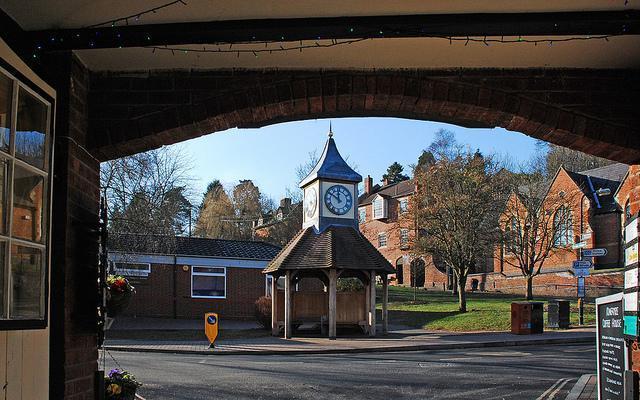How many clocks are visible?
Give a very brief answer. 2. How many birds are flying in the picture?
Give a very brief answer. 0. 